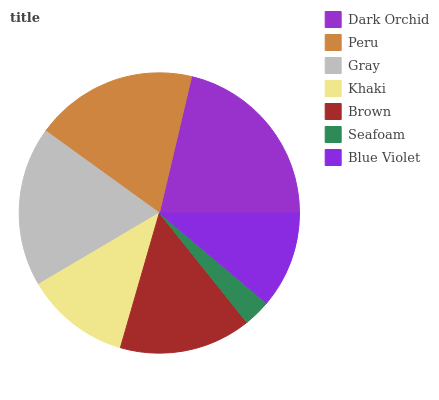Is Seafoam the minimum?
Answer yes or no. Yes. Is Dark Orchid the maximum?
Answer yes or no. Yes. Is Peru the minimum?
Answer yes or no. No. Is Peru the maximum?
Answer yes or no. No. Is Dark Orchid greater than Peru?
Answer yes or no. Yes. Is Peru less than Dark Orchid?
Answer yes or no. Yes. Is Peru greater than Dark Orchid?
Answer yes or no. No. Is Dark Orchid less than Peru?
Answer yes or no. No. Is Brown the high median?
Answer yes or no. Yes. Is Brown the low median?
Answer yes or no. Yes. Is Gray the high median?
Answer yes or no. No. Is Blue Violet the low median?
Answer yes or no. No. 